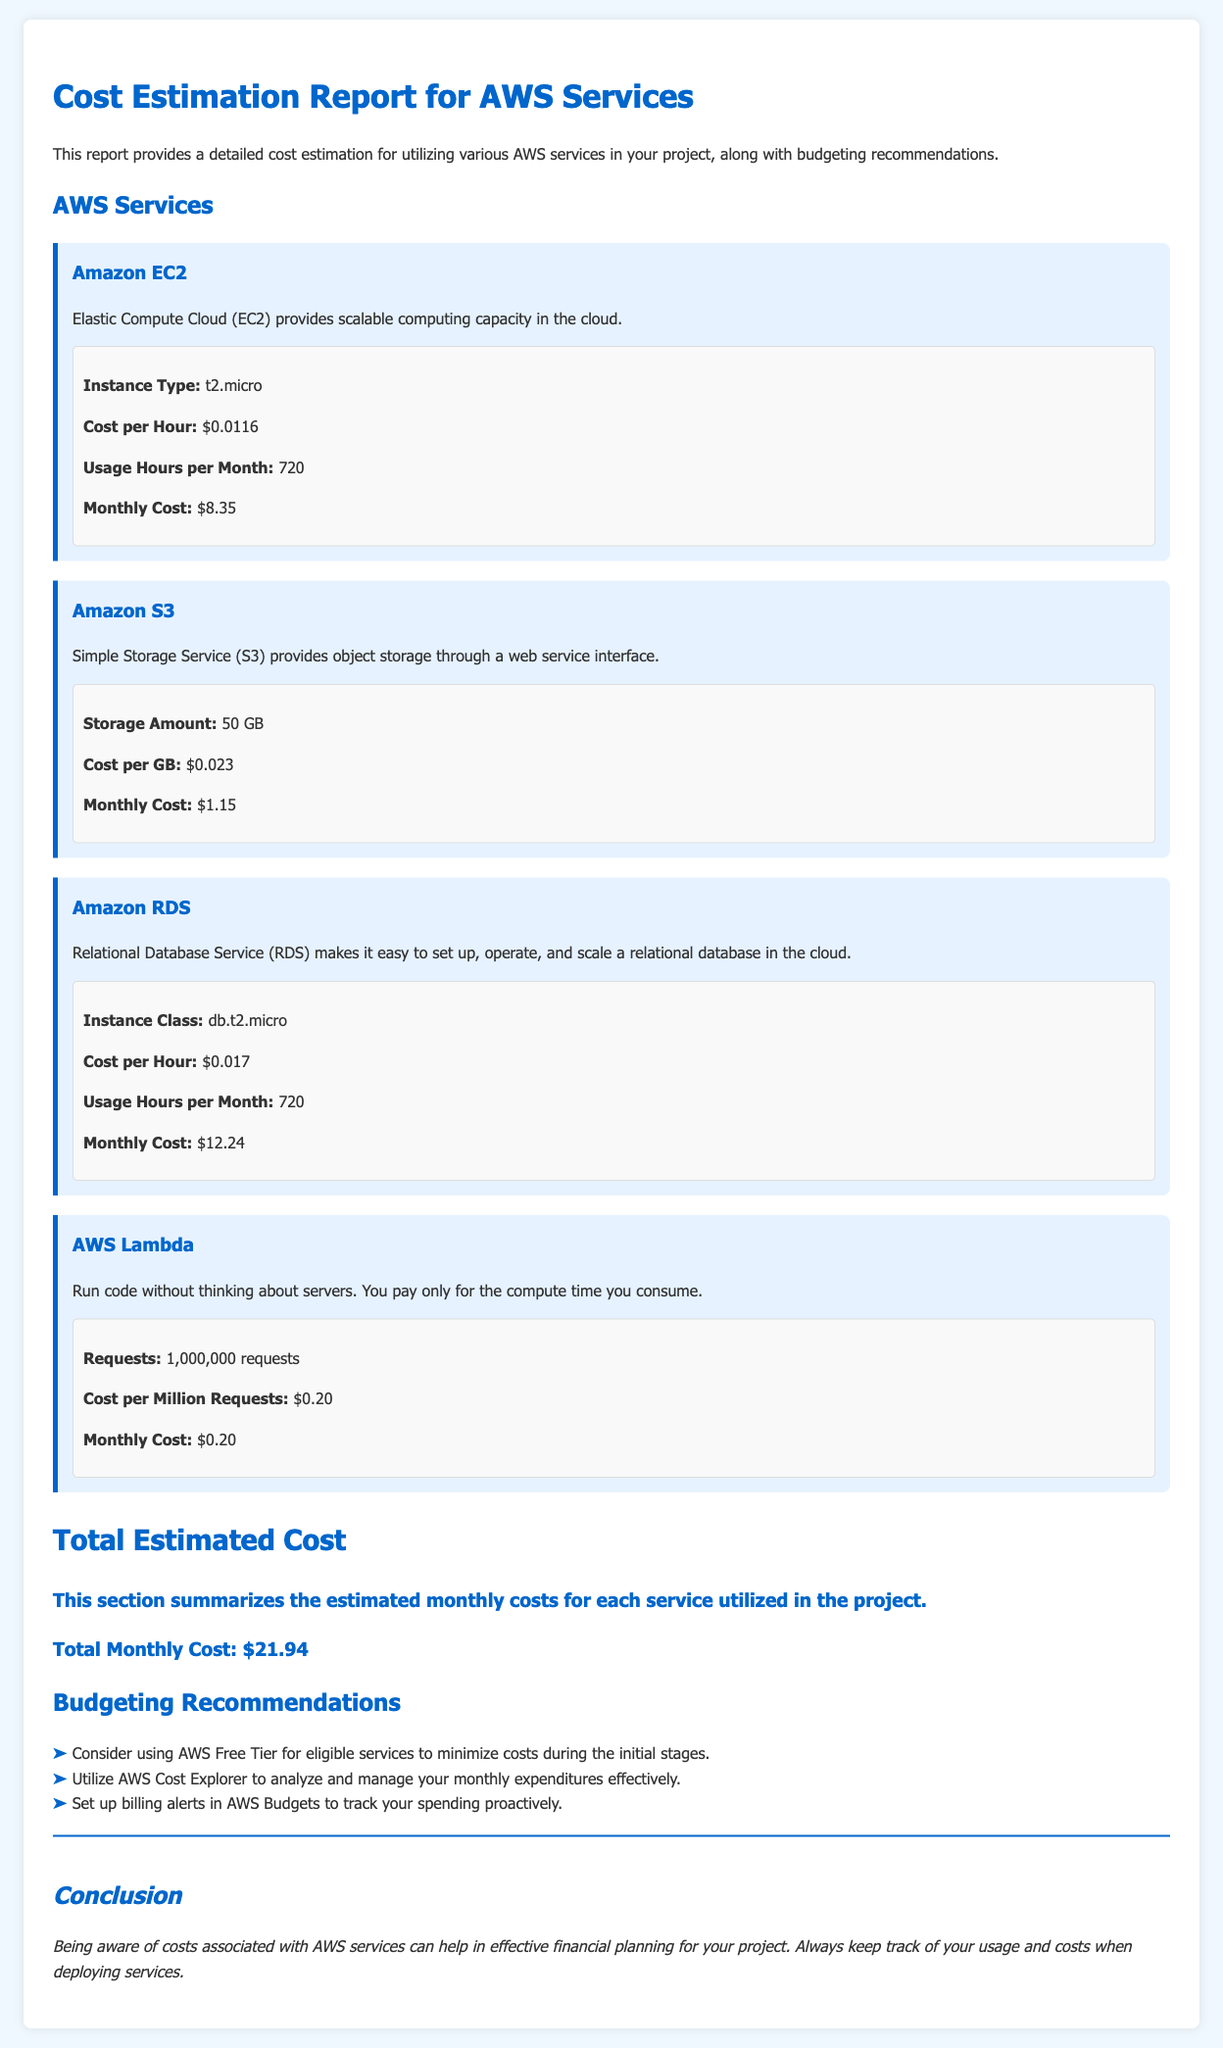What is the instance type for Amazon EC2? The document states that the instance type for Amazon EC2 is t2.micro.
Answer: t2.micro What is the monthly cost for Amazon S3? The document specifies that the monthly cost for Amazon S3 is $1.15.
Answer: $1.15 How much does AWS Lambda cost per million requests? According to the document, the cost per million requests for AWS Lambda is $0.20.
Answer: $0.20 What is the total monthly cost for all services? The document sums the costs and indicates that the total monthly cost is $21.94.
Answer: $21.94 What is a recommendation for minimizing costs with AWS services? The document suggests considering using AWS Free Tier for eligible services to minimize costs during the initial stages.
Answer: AWS Free Tier What is the cost per hour for Amazon RDS? The document outlines that the cost per hour for Amazon RDS is $0.017.
Answer: $0.017 How many usage hours per month are considered for the Amazon EC2 pricing? The document specifies that there are 720 usage hours per month for Amazon EC2.
Answer: 720 What should be set up in AWS Budgets to track spending? The document advises setting up billing alerts to track spending proactively.
Answer: Billing alerts 